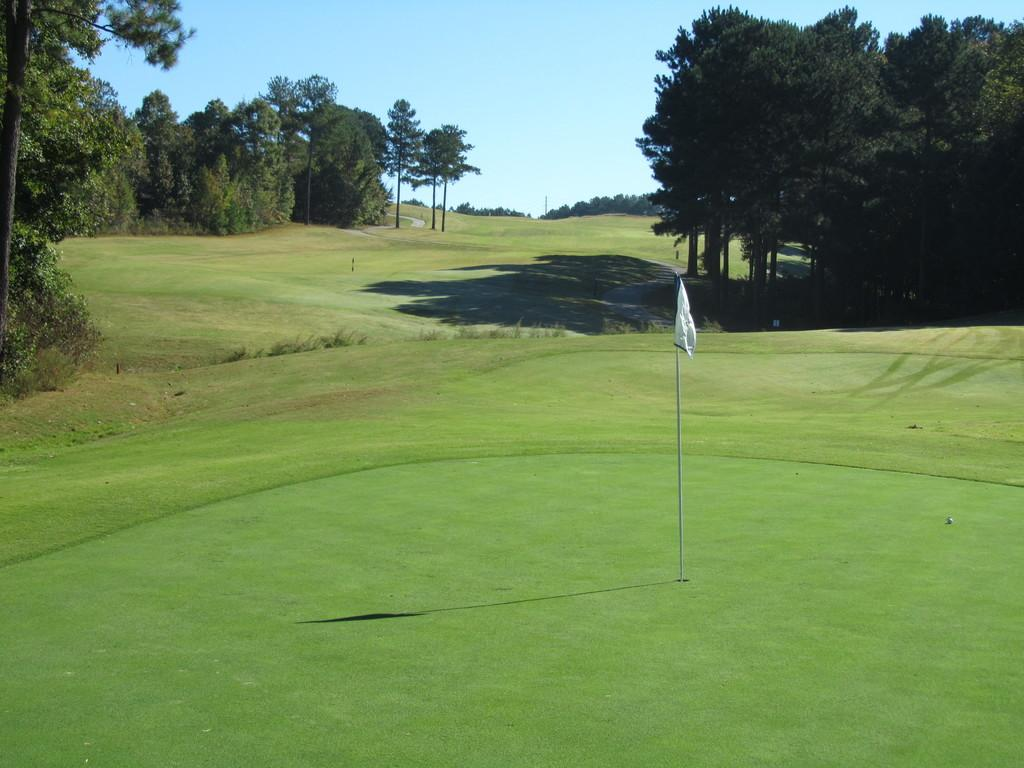What is the main object in the image? There is a white cloth with a pole in the image. What type of terrain is visible at the bottom of the image? Grass is present at the bottom of the image. What can be seen in the background of the image? There are trees, plants, and the sky visible in the background of the image. How many flies are sitting on the white cloth in the image? There are no flies present in the image. What type of system is responsible for the arrangement of the plants in the background? The image does not provide information about a system responsible for the arrangement of the plants in the background. 